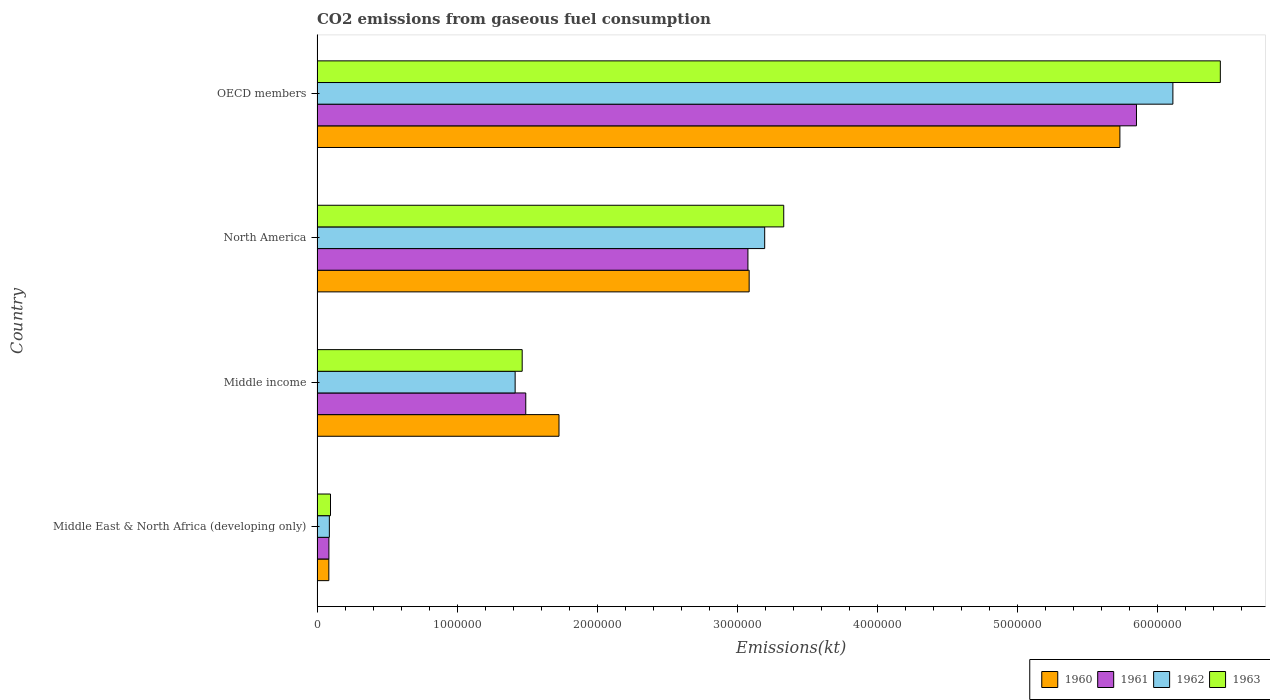How many different coloured bars are there?
Offer a terse response. 4. How many groups of bars are there?
Give a very brief answer. 4. Are the number of bars per tick equal to the number of legend labels?
Your answer should be very brief. Yes. Are the number of bars on each tick of the Y-axis equal?
Give a very brief answer. Yes. How many bars are there on the 3rd tick from the top?
Ensure brevity in your answer.  4. In how many cases, is the number of bars for a given country not equal to the number of legend labels?
Give a very brief answer. 0. What is the amount of CO2 emitted in 1960 in North America?
Offer a terse response. 3.08e+06. Across all countries, what is the maximum amount of CO2 emitted in 1962?
Make the answer very short. 6.11e+06. Across all countries, what is the minimum amount of CO2 emitted in 1963?
Provide a short and direct response. 9.60e+04. In which country was the amount of CO2 emitted in 1963 maximum?
Keep it short and to the point. OECD members. In which country was the amount of CO2 emitted in 1960 minimum?
Give a very brief answer. Middle East & North Africa (developing only). What is the total amount of CO2 emitted in 1962 in the graph?
Provide a succinct answer. 1.08e+07. What is the difference between the amount of CO2 emitted in 1963 in Middle income and that in North America?
Make the answer very short. -1.87e+06. What is the difference between the amount of CO2 emitted in 1960 in North America and the amount of CO2 emitted in 1962 in Middle East & North Africa (developing only)?
Provide a short and direct response. 3.00e+06. What is the average amount of CO2 emitted in 1963 per country?
Your answer should be compact. 2.83e+06. What is the difference between the amount of CO2 emitted in 1963 and amount of CO2 emitted in 1961 in OECD members?
Give a very brief answer. 5.99e+05. What is the ratio of the amount of CO2 emitted in 1961 in Middle income to that in OECD members?
Your answer should be compact. 0.25. Is the amount of CO2 emitted in 1962 in Middle East & North Africa (developing only) less than that in OECD members?
Give a very brief answer. Yes. Is the difference between the amount of CO2 emitted in 1963 in Middle East & North Africa (developing only) and North America greater than the difference between the amount of CO2 emitted in 1961 in Middle East & North Africa (developing only) and North America?
Your answer should be compact. No. What is the difference between the highest and the second highest amount of CO2 emitted in 1961?
Provide a succinct answer. 2.77e+06. What is the difference between the highest and the lowest amount of CO2 emitted in 1960?
Offer a very short reply. 5.65e+06. In how many countries, is the amount of CO2 emitted in 1961 greater than the average amount of CO2 emitted in 1961 taken over all countries?
Provide a succinct answer. 2. Is the sum of the amount of CO2 emitted in 1963 in Middle East & North Africa (developing only) and North America greater than the maximum amount of CO2 emitted in 1961 across all countries?
Provide a short and direct response. No. Is it the case that in every country, the sum of the amount of CO2 emitted in 1963 and amount of CO2 emitted in 1961 is greater than the sum of amount of CO2 emitted in 1962 and amount of CO2 emitted in 1960?
Your answer should be very brief. No. What does the 4th bar from the bottom in OECD members represents?
Offer a terse response. 1963. Is it the case that in every country, the sum of the amount of CO2 emitted in 1960 and amount of CO2 emitted in 1961 is greater than the amount of CO2 emitted in 1962?
Make the answer very short. Yes. How many bars are there?
Offer a terse response. 16. Are all the bars in the graph horizontal?
Your answer should be very brief. Yes. What is the difference between two consecutive major ticks on the X-axis?
Ensure brevity in your answer.  1.00e+06. Does the graph contain grids?
Give a very brief answer. No. Where does the legend appear in the graph?
Provide a short and direct response. Bottom right. How many legend labels are there?
Ensure brevity in your answer.  4. How are the legend labels stacked?
Provide a short and direct response. Horizontal. What is the title of the graph?
Make the answer very short. CO2 emissions from gaseous fuel consumption. What is the label or title of the X-axis?
Give a very brief answer. Emissions(kt). What is the Emissions(kt) in 1960 in Middle East & North Africa (developing only)?
Your answer should be compact. 8.42e+04. What is the Emissions(kt) in 1961 in Middle East & North Africa (developing only)?
Offer a terse response. 8.46e+04. What is the Emissions(kt) in 1962 in Middle East & North Africa (developing only)?
Ensure brevity in your answer.  8.78e+04. What is the Emissions(kt) of 1963 in Middle East & North Africa (developing only)?
Offer a very short reply. 9.60e+04. What is the Emissions(kt) of 1960 in Middle income?
Ensure brevity in your answer.  1.73e+06. What is the Emissions(kt) in 1961 in Middle income?
Your response must be concise. 1.49e+06. What is the Emissions(kt) of 1962 in Middle income?
Ensure brevity in your answer.  1.41e+06. What is the Emissions(kt) in 1963 in Middle income?
Your answer should be compact. 1.46e+06. What is the Emissions(kt) of 1960 in North America?
Your response must be concise. 3.08e+06. What is the Emissions(kt) in 1961 in North America?
Make the answer very short. 3.07e+06. What is the Emissions(kt) in 1962 in North America?
Offer a very short reply. 3.19e+06. What is the Emissions(kt) in 1963 in North America?
Give a very brief answer. 3.33e+06. What is the Emissions(kt) of 1960 in OECD members?
Your response must be concise. 5.73e+06. What is the Emissions(kt) in 1961 in OECD members?
Offer a very short reply. 5.85e+06. What is the Emissions(kt) of 1962 in OECD members?
Make the answer very short. 6.11e+06. What is the Emissions(kt) of 1963 in OECD members?
Your response must be concise. 6.45e+06. Across all countries, what is the maximum Emissions(kt) in 1960?
Your answer should be very brief. 5.73e+06. Across all countries, what is the maximum Emissions(kt) of 1961?
Offer a terse response. 5.85e+06. Across all countries, what is the maximum Emissions(kt) of 1962?
Make the answer very short. 6.11e+06. Across all countries, what is the maximum Emissions(kt) of 1963?
Give a very brief answer. 6.45e+06. Across all countries, what is the minimum Emissions(kt) of 1960?
Make the answer very short. 8.42e+04. Across all countries, what is the minimum Emissions(kt) of 1961?
Provide a succinct answer. 8.46e+04. Across all countries, what is the minimum Emissions(kt) of 1962?
Make the answer very short. 8.78e+04. Across all countries, what is the minimum Emissions(kt) in 1963?
Your answer should be compact. 9.60e+04. What is the total Emissions(kt) of 1960 in the graph?
Your response must be concise. 1.06e+07. What is the total Emissions(kt) of 1961 in the graph?
Offer a terse response. 1.05e+07. What is the total Emissions(kt) of 1962 in the graph?
Offer a terse response. 1.08e+07. What is the total Emissions(kt) of 1963 in the graph?
Make the answer very short. 1.13e+07. What is the difference between the Emissions(kt) in 1960 in Middle East & North Africa (developing only) and that in Middle income?
Your answer should be compact. -1.64e+06. What is the difference between the Emissions(kt) in 1961 in Middle East & North Africa (developing only) and that in Middle income?
Offer a very short reply. -1.40e+06. What is the difference between the Emissions(kt) of 1962 in Middle East & North Africa (developing only) and that in Middle income?
Your answer should be compact. -1.33e+06. What is the difference between the Emissions(kt) of 1963 in Middle East & North Africa (developing only) and that in Middle income?
Offer a terse response. -1.37e+06. What is the difference between the Emissions(kt) in 1960 in Middle East & North Africa (developing only) and that in North America?
Offer a very short reply. -3.00e+06. What is the difference between the Emissions(kt) in 1961 in Middle East & North Africa (developing only) and that in North America?
Provide a short and direct response. -2.99e+06. What is the difference between the Emissions(kt) of 1962 in Middle East & North Africa (developing only) and that in North America?
Give a very brief answer. -3.11e+06. What is the difference between the Emissions(kt) of 1963 in Middle East & North Africa (developing only) and that in North America?
Make the answer very short. -3.23e+06. What is the difference between the Emissions(kt) in 1960 in Middle East & North Africa (developing only) and that in OECD members?
Your response must be concise. -5.65e+06. What is the difference between the Emissions(kt) in 1961 in Middle East & North Africa (developing only) and that in OECD members?
Offer a terse response. -5.76e+06. What is the difference between the Emissions(kt) in 1962 in Middle East & North Africa (developing only) and that in OECD members?
Ensure brevity in your answer.  -6.02e+06. What is the difference between the Emissions(kt) of 1963 in Middle East & North Africa (developing only) and that in OECD members?
Your answer should be very brief. -6.35e+06. What is the difference between the Emissions(kt) of 1960 in Middle income and that in North America?
Provide a short and direct response. -1.36e+06. What is the difference between the Emissions(kt) in 1961 in Middle income and that in North America?
Offer a very short reply. -1.59e+06. What is the difference between the Emissions(kt) of 1962 in Middle income and that in North America?
Your answer should be compact. -1.78e+06. What is the difference between the Emissions(kt) of 1963 in Middle income and that in North America?
Offer a terse response. -1.87e+06. What is the difference between the Emissions(kt) of 1960 in Middle income and that in OECD members?
Offer a very short reply. -4.00e+06. What is the difference between the Emissions(kt) of 1961 in Middle income and that in OECD members?
Your answer should be compact. -4.36e+06. What is the difference between the Emissions(kt) of 1962 in Middle income and that in OECD members?
Provide a succinct answer. -4.69e+06. What is the difference between the Emissions(kt) in 1963 in Middle income and that in OECD members?
Keep it short and to the point. -4.98e+06. What is the difference between the Emissions(kt) in 1960 in North America and that in OECD members?
Give a very brief answer. -2.65e+06. What is the difference between the Emissions(kt) of 1961 in North America and that in OECD members?
Ensure brevity in your answer.  -2.77e+06. What is the difference between the Emissions(kt) of 1962 in North America and that in OECD members?
Your answer should be compact. -2.91e+06. What is the difference between the Emissions(kt) of 1963 in North America and that in OECD members?
Provide a succinct answer. -3.12e+06. What is the difference between the Emissions(kt) of 1960 in Middle East & North Africa (developing only) and the Emissions(kt) of 1961 in Middle income?
Your answer should be compact. -1.41e+06. What is the difference between the Emissions(kt) in 1960 in Middle East & North Africa (developing only) and the Emissions(kt) in 1962 in Middle income?
Make the answer very short. -1.33e+06. What is the difference between the Emissions(kt) in 1960 in Middle East & North Africa (developing only) and the Emissions(kt) in 1963 in Middle income?
Offer a terse response. -1.38e+06. What is the difference between the Emissions(kt) of 1961 in Middle East & North Africa (developing only) and the Emissions(kt) of 1962 in Middle income?
Your response must be concise. -1.33e+06. What is the difference between the Emissions(kt) in 1961 in Middle East & North Africa (developing only) and the Emissions(kt) in 1963 in Middle income?
Provide a succinct answer. -1.38e+06. What is the difference between the Emissions(kt) of 1962 in Middle East & North Africa (developing only) and the Emissions(kt) of 1963 in Middle income?
Keep it short and to the point. -1.38e+06. What is the difference between the Emissions(kt) of 1960 in Middle East & North Africa (developing only) and the Emissions(kt) of 1961 in North America?
Give a very brief answer. -2.99e+06. What is the difference between the Emissions(kt) of 1960 in Middle East & North Africa (developing only) and the Emissions(kt) of 1962 in North America?
Ensure brevity in your answer.  -3.11e+06. What is the difference between the Emissions(kt) in 1960 in Middle East & North Africa (developing only) and the Emissions(kt) in 1963 in North America?
Keep it short and to the point. -3.25e+06. What is the difference between the Emissions(kt) of 1961 in Middle East & North Africa (developing only) and the Emissions(kt) of 1962 in North America?
Your response must be concise. -3.11e+06. What is the difference between the Emissions(kt) in 1961 in Middle East & North Africa (developing only) and the Emissions(kt) in 1963 in North America?
Keep it short and to the point. -3.25e+06. What is the difference between the Emissions(kt) of 1962 in Middle East & North Africa (developing only) and the Emissions(kt) of 1963 in North America?
Your response must be concise. -3.24e+06. What is the difference between the Emissions(kt) in 1960 in Middle East & North Africa (developing only) and the Emissions(kt) in 1961 in OECD members?
Keep it short and to the point. -5.76e+06. What is the difference between the Emissions(kt) in 1960 in Middle East & North Africa (developing only) and the Emissions(kt) in 1962 in OECD members?
Ensure brevity in your answer.  -6.02e+06. What is the difference between the Emissions(kt) in 1960 in Middle East & North Africa (developing only) and the Emissions(kt) in 1963 in OECD members?
Provide a short and direct response. -6.36e+06. What is the difference between the Emissions(kt) of 1961 in Middle East & North Africa (developing only) and the Emissions(kt) of 1962 in OECD members?
Provide a short and direct response. -6.02e+06. What is the difference between the Emissions(kt) in 1961 in Middle East & North Africa (developing only) and the Emissions(kt) in 1963 in OECD members?
Provide a short and direct response. -6.36e+06. What is the difference between the Emissions(kt) of 1962 in Middle East & North Africa (developing only) and the Emissions(kt) of 1963 in OECD members?
Ensure brevity in your answer.  -6.36e+06. What is the difference between the Emissions(kt) in 1960 in Middle income and the Emissions(kt) in 1961 in North America?
Your response must be concise. -1.35e+06. What is the difference between the Emissions(kt) of 1960 in Middle income and the Emissions(kt) of 1962 in North America?
Provide a short and direct response. -1.47e+06. What is the difference between the Emissions(kt) of 1960 in Middle income and the Emissions(kt) of 1963 in North America?
Ensure brevity in your answer.  -1.60e+06. What is the difference between the Emissions(kt) in 1961 in Middle income and the Emissions(kt) in 1962 in North America?
Offer a very short reply. -1.71e+06. What is the difference between the Emissions(kt) of 1961 in Middle income and the Emissions(kt) of 1963 in North America?
Your answer should be compact. -1.84e+06. What is the difference between the Emissions(kt) in 1962 in Middle income and the Emissions(kt) in 1963 in North America?
Give a very brief answer. -1.92e+06. What is the difference between the Emissions(kt) of 1960 in Middle income and the Emissions(kt) of 1961 in OECD members?
Keep it short and to the point. -4.12e+06. What is the difference between the Emissions(kt) in 1960 in Middle income and the Emissions(kt) in 1962 in OECD members?
Give a very brief answer. -4.38e+06. What is the difference between the Emissions(kt) in 1960 in Middle income and the Emissions(kt) in 1963 in OECD members?
Keep it short and to the point. -4.72e+06. What is the difference between the Emissions(kt) of 1961 in Middle income and the Emissions(kt) of 1962 in OECD members?
Give a very brief answer. -4.62e+06. What is the difference between the Emissions(kt) in 1961 in Middle income and the Emissions(kt) in 1963 in OECD members?
Your answer should be very brief. -4.96e+06. What is the difference between the Emissions(kt) in 1962 in Middle income and the Emissions(kt) in 1963 in OECD members?
Ensure brevity in your answer.  -5.03e+06. What is the difference between the Emissions(kt) of 1960 in North America and the Emissions(kt) of 1961 in OECD members?
Offer a terse response. -2.76e+06. What is the difference between the Emissions(kt) of 1960 in North America and the Emissions(kt) of 1962 in OECD members?
Ensure brevity in your answer.  -3.02e+06. What is the difference between the Emissions(kt) of 1960 in North America and the Emissions(kt) of 1963 in OECD members?
Provide a succinct answer. -3.36e+06. What is the difference between the Emissions(kt) of 1961 in North America and the Emissions(kt) of 1962 in OECD members?
Provide a succinct answer. -3.03e+06. What is the difference between the Emissions(kt) in 1961 in North America and the Emissions(kt) in 1963 in OECD members?
Your response must be concise. -3.37e+06. What is the difference between the Emissions(kt) in 1962 in North America and the Emissions(kt) in 1963 in OECD members?
Offer a very short reply. -3.25e+06. What is the average Emissions(kt) in 1960 per country?
Ensure brevity in your answer.  2.66e+06. What is the average Emissions(kt) in 1961 per country?
Your response must be concise. 2.62e+06. What is the average Emissions(kt) in 1962 per country?
Your response must be concise. 2.70e+06. What is the average Emissions(kt) of 1963 per country?
Offer a terse response. 2.83e+06. What is the difference between the Emissions(kt) in 1960 and Emissions(kt) in 1961 in Middle East & North Africa (developing only)?
Ensure brevity in your answer.  -436.61. What is the difference between the Emissions(kt) in 1960 and Emissions(kt) in 1962 in Middle East & North Africa (developing only)?
Offer a very short reply. -3573.64. What is the difference between the Emissions(kt) in 1960 and Emissions(kt) in 1963 in Middle East & North Africa (developing only)?
Your response must be concise. -1.18e+04. What is the difference between the Emissions(kt) of 1961 and Emissions(kt) of 1962 in Middle East & North Africa (developing only)?
Give a very brief answer. -3137.02. What is the difference between the Emissions(kt) in 1961 and Emissions(kt) in 1963 in Middle East & North Africa (developing only)?
Your answer should be compact. -1.13e+04. What is the difference between the Emissions(kt) of 1962 and Emissions(kt) of 1963 in Middle East & North Africa (developing only)?
Provide a short and direct response. -8211.29. What is the difference between the Emissions(kt) in 1960 and Emissions(kt) in 1961 in Middle income?
Give a very brief answer. 2.37e+05. What is the difference between the Emissions(kt) in 1960 and Emissions(kt) in 1962 in Middle income?
Provide a succinct answer. 3.13e+05. What is the difference between the Emissions(kt) in 1960 and Emissions(kt) in 1963 in Middle income?
Offer a very short reply. 2.63e+05. What is the difference between the Emissions(kt) in 1961 and Emissions(kt) in 1962 in Middle income?
Offer a terse response. 7.58e+04. What is the difference between the Emissions(kt) of 1961 and Emissions(kt) of 1963 in Middle income?
Provide a succinct answer. 2.55e+04. What is the difference between the Emissions(kt) in 1962 and Emissions(kt) in 1963 in Middle income?
Your answer should be very brief. -5.03e+04. What is the difference between the Emissions(kt) in 1960 and Emissions(kt) in 1961 in North America?
Your answer should be compact. 8885.14. What is the difference between the Emissions(kt) of 1960 and Emissions(kt) of 1962 in North America?
Ensure brevity in your answer.  -1.11e+05. What is the difference between the Emissions(kt) of 1960 and Emissions(kt) of 1963 in North America?
Ensure brevity in your answer.  -2.47e+05. What is the difference between the Emissions(kt) in 1961 and Emissions(kt) in 1962 in North America?
Your answer should be very brief. -1.20e+05. What is the difference between the Emissions(kt) of 1961 and Emissions(kt) of 1963 in North America?
Provide a short and direct response. -2.56e+05. What is the difference between the Emissions(kt) in 1962 and Emissions(kt) in 1963 in North America?
Give a very brief answer. -1.36e+05. What is the difference between the Emissions(kt) in 1960 and Emissions(kt) in 1961 in OECD members?
Give a very brief answer. -1.18e+05. What is the difference between the Emissions(kt) of 1960 and Emissions(kt) of 1962 in OECD members?
Your answer should be compact. -3.78e+05. What is the difference between the Emissions(kt) of 1960 and Emissions(kt) of 1963 in OECD members?
Your response must be concise. -7.17e+05. What is the difference between the Emissions(kt) of 1961 and Emissions(kt) of 1962 in OECD members?
Provide a short and direct response. -2.60e+05. What is the difference between the Emissions(kt) of 1961 and Emissions(kt) of 1963 in OECD members?
Your response must be concise. -5.99e+05. What is the difference between the Emissions(kt) in 1962 and Emissions(kt) in 1963 in OECD members?
Keep it short and to the point. -3.39e+05. What is the ratio of the Emissions(kt) of 1960 in Middle East & North Africa (developing only) to that in Middle income?
Offer a very short reply. 0.05. What is the ratio of the Emissions(kt) of 1961 in Middle East & North Africa (developing only) to that in Middle income?
Offer a terse response. 0.06. What is the ratio of the Emissions(kt) of 1962 in Middle East & North Africa (developing only) to that in Middle income?
Ensure brevity in your answer.  0.06. What is the ratio of the Emissions(kt) of 1963 in Middle East & North Africa (developing only) to that in Middle income?
Provide a succinct answer. 0.07. What is the ratio of the Emissions(kt) in 1960 in Middle East & North Africa (developing only) to that in North America?
Make the answer very short. 0.03. What is the ratio of the Emissions(kt) in 1961 in Middle East & North Africa (developing only) to that in North America?
Ensure brevity in your answer.  0.03. What is the ratio of the Emissions(kt) in 1962 in Middle East & North Africa (developing only) to that in North America?
Your response must be concise. 0.03. What is the ratio of the Emissions(kt) of 1963 in Middle East & North Africa (developing only) to that in North America?
Offer a terse response. 0.03. What is the ratio of the Emissions(kt) in 1960 in Middle East & North Africa (developing only) to that in OECD members?
Your response must be concise. 0.01. What is the ratio of the Emissions(kt) in 1961 in Middle East & North Africa (developing only) to that in OECD members?
Ensure brevity in your answer.  0.01. What is the ratio of the Emissions(kt) of 1962 in Middle East & North Africa (developing only) to that in OECD members?
Your answer should be very brief. 0.01. What is the ratio of the Emissions(kt) of 1963 in Middle East & North Africa (developing only) to that in OECD members?
Your answer should be very brief. 0.01. What is the ratio of the Emissions(kt) of 1960 in Middle income to that in North America?
Your answer should be compact. 0.56. What is the ratio of the Emissions(kt) of 1961 in Middle income to that in North America?
Offer a very short reply. 0.48. What is the ratio of the Emissions(kt) of 1962 in Middle income to that in North America?
Offer a very short reply. 0.44. What is the ratio of the Emissions(kt) of 1963 in Middle income to that in North America?
Offer a very short reply. 0.44. What is the ratio of the Emissions(kt) of 1960 in Middle income to that in OECD members?
Your answer should be very brief. 0.3. What is the ratio of the Emissions(kt) in 1961 in Middle income to that in OECD members?
Ensure brevity in your answer.  0.25. What is the ratio of the Emissions(kt) of 1962 in Middle income to that in OECD members?
Ensure brevity in your answer.  0.23. What is the ratio of the Emissions(kt) of 1963 in Middle income to that in OECD members?
Make the answer very short. 0.23. What is the ratio of the Emissions(kt) in 1960 in North America to that in OECD members?
Offer a terse response. 0.54. What is the ratio of the Emissions(kt) of 1961 in North America to that in OECD members?
Your answer should be compact. 0.53. What is the ratio of the Emissions(kt) in 1962 in North America to that in OECD members?
Offer a terse response. 0.52. What is the ratio of the Emissions(kt) in 1963 in North America to that in OECD members?
Your response must be concise. 0.52. What is the difference between the highest and the second highest Emissions(kt) in 1960?
Keep it short and to the point. 2.65e+06. What is the difference between the highest and the second highest Emissions(kt) of 1961?
Your answer should be very brief. 2.77e+06. What is the difference between the highest and the second highest Emissions(kt) in 1962?
Keep it short and to the point. 2.91e+06. What is the difference between the highest and the second highest Emissions(kt) of 1963?
Your response must be concise. 3.12e+06. What is the difference between the highest and the lowest Emissions(kt) of 1960?
Provide a short and direct response. 5.65e+06. What is the difference between the highest and the lowest Emissions(kt) of 1961?
Keep it short and to the point. 5.76e+06. What is the difference between the highest and the lowest Emissions(kt) in 1962?
Offer a very short reply. 6.02e+06. What is the difference between the highest and the lowest Emissions(kt) in 1963?
Your answer should be compact. 6.35e+06. 